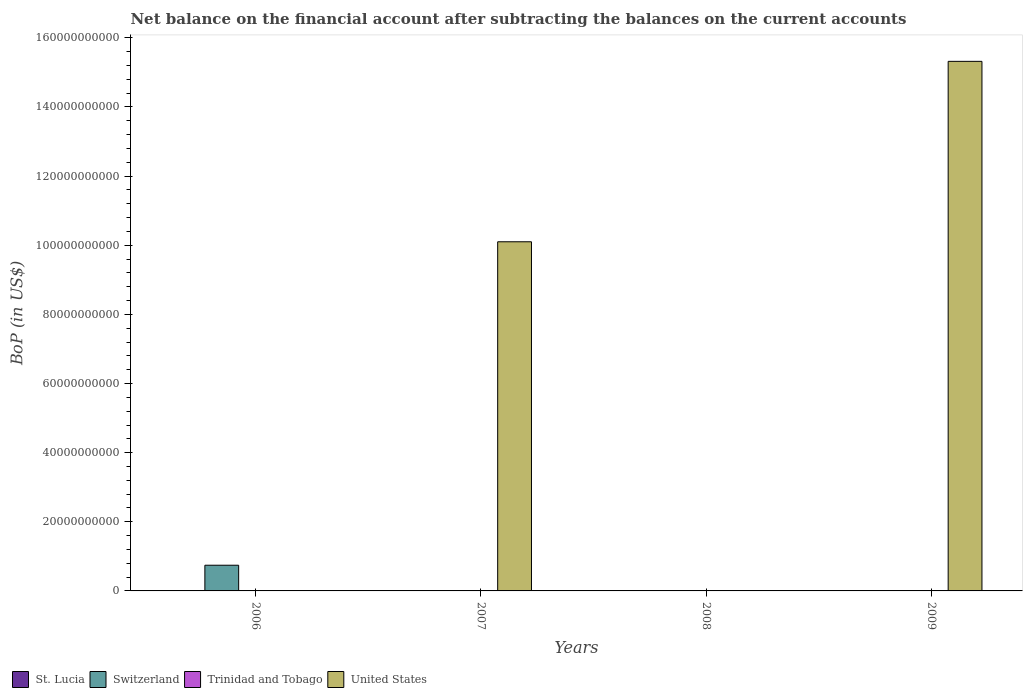Are the number of bars on each tick of the X-axis equal?
Your answer should be very brief. No. How many bars are there on the 3rd tick from the left?
Offer a very short reply. 1. How many bars are there on the 4th tick from the right?
Ensure brevity in your answer.  2. What is the label of the 1st group of bars from the left?
Provide a short and direct response. 2006. In how many cases, is the number of bars for a given year not equal to the number of legend labels?
Offer a very short reply. 4. What is the Balance of Payments in Trinidad and Tobago in 2008?
Offer a terse response. 9.70e+07. Across all years, what is the maximum Balance of Payments in St. Lucia?
Your response must be concise. 2.96e+06. Across all years, what is the minimum Balance of Payments in St. Lucia?
Provide a succinct answer. 0. What is the total Balance of Payments in United States in the graph?
Offer a terse response. 2.54e+11. What is the difference between the Balance of Payments in United States in 2007 and that in 2009?
Keep it short and to the point. -5.22e+1. What is the difference between the Balance of Payments in United States in 2009 and the Balance of Payments in Trinidad and Tobago in 2006?
Ensure brevity in your answer.  1.53e+11. What is the average Balance of Payments in Switzerland per year?
Offer a very short reply. 1.86e+09. In the year 2006, what is the difference between the Balance of Payments in St. Lucia and Balance of Payments in Switzerland?
Your answer should be very brief. -7.43e+09. What is the ratio of the Balance of Payments in Trinidad and Tobago in 2008 to that in 2009?
Keep it short and to the point. 13.61. What is the difference between the highest and the lowest Balance of Payments in Switzerland?
Your answer should be very brief. 7.43e+09. In how many years, is the Balance of Payments in St. Lucia greater than the average Balance of Payments in St. Lucia taken over all years?
Make the answer very short. 1. Is it the case that in every year, the sum of the Balance of Payments in St. Lucia and Balance of Payments in United States is greater than the sum of Balance of Payments in Switzerland and Balance of Payments in Trinidad and Tobago?
Your answer should be very brief. No. How many bars are there?
Offer a very short reply. 7. How many years are there in the graph?
Provide a succinct answer. 4. What is the difference between two consecutive major ticks on the Y-axis?
Your answer should be compact. 2.00e+1. Does the graph contain grids?
Provide a succinct answer. No. Where does the legend appear in the graph?
Provide a succinct answer. Bottom left. How are the legend labels stacked?
Make the answer very short. Horizontal. What is the title of the graph?
Your answer should be compact. Net balance on the financial account after subtracting the balances on the current accounts. Does "Thailand" appear as one of the legend labels in the graph?
Make the answer very short. No. What is the label or title of the X-axis?
Give a very brief answer. Years. What is the label or title of the Y-axis?
Offer a very short reply. BoP (in US$). What is the BoP (in US$) of St. Lucia in 2006?
Your response must be concise. 2.96e+06. What is the BoP (in US$) in Switzerland in 2006?
Provide a short and direct response. 7.43e+09. What is the BoP (in US$) of United States in 2006?
Your answer should be compact. 0. What is the BoP (in US$) in St. Lucia in 2007?
Provide a succinct answer. 4.53e+04. What is the BoP (in US$) of Switzerland in 2007?
Ensure brevity in your answer.  0. What is the BoP (in US$) in Trinidad and Tobago in 2007?
Offer a very short reply. 0. What is the BoP (in US$) of United States in 2007?
Keep it short and to the point. 1.01e+11. What is the BoP (in US$) in St. Lucia in 2008?
Make the answer very short. 0. What is the BoP (in US$) in Switzerland in 2008?
Give a very brief answer. 0. What is the BoP (in US$) of Trinidad and Tobago in 2008?
Your answer should be compact. 9.70e+07. What is the BoP (in US$) in United States in 2008?
Offer a terse response. 0. What is the BoP (in US$) in Switzerland in 2009?
Keep it short and to the point. 0. What is the BoP (in US$) in Trinidad and Tobago in 2009?
Offer a terse response. 7.12e+06. What is the BoP (in US$) in United States in 2009?
Your answer should be compact. 1.53e+11. Across all years, what is the maximum BoP (in US$) in St. Lucia?
Give a very brief answer. 2.96e+06. Across all years, what is the maximum BoP (in US$) of Switzerland?
Your answer should be compact. 7.43e+09. Across all years, what is the maximum BoP (in US$) of Trinidad and Tobago?
Give a very brief answer. 9.70e+07. Across all years, what is the maximum BoP (in US$) of United States?
Make the answer very short. 1.53e+11. Across all years, what is the minimum BoP (in US$) of St. Lucia?
Your answer should be very brief. 0. Across all years, what is the minimum BoP (in US$) in Trinidad and Tobago?
Your response must be concise. 0. What is the total BoP (in US$) in St. Lucia in the graph?
Provide a succinct answer. 3.01e+06. What is the total BoP (in US$) of Switzerland in the graph?
Keep it short and to the point. 7.43e+09. What is the total BoP (in US$) of Trinidad and Tobago in the graph?
Ensure brevity in your answer.  1.04e+08. What is the total BoP (in US$) in United States in the graph?
Make the answer very short. 2.54e+11. What is the difference between the BoP (in US$) of St. Lucia in 2006 and that in 2007?
Offer a terse response. 2.92e+06. What is the difference between the BoP (in US$) in United States in 2007 and that in 2009?
Make the answer very short. -5.22e+1. What is the difference between the BoP (in US$) in Trinidad and Tobago in 2008 and that in 2009?
Provide a short and direct response. 8.98e+07. What is the difference between the BoP (in US$) in St. Lucia in 2006 and the BoP (in US$) in United States in 2007?
Provide a succinct answer. -1.01e+11. What is the difference between the BoP (in US$) in Switzerland in 2006 and the BoP (in US$) in United States in 2007?
Your answer should be compact. -9.36e+1. What is the difference between the BoP (in US$) in St. Lucia in 2006 and the BoP (in US$) in Trinidad and Tobago in 2008?
Your answer should be compact. -9.40e+07. What is the difference between the BoP (in US$) in Switzerland in 2006 and the BoP (in US$) in Trinidad and Tobago in 2008?
Make the answer very short. 7.34e+09. What is the difference between the BoP (in US$) in St. Lucia in 2006 and the BoP (in US$) in Trinidad and Tobago in 2009?
Your answer should be compact. -4.16e+06. What is the difference between the BoP (in US$) in St. Lucia in 2006 and the BoP (in US$) in United States in 2009?
Make the answer very short. -1.53e+11. What is the difference between the BoP (in US$) of Switzerland in 2006 and the BoP (in US$) of Trinidad and Tobago in 2009?
Offer a very short reply. 7.43e+09. What is the difference between the BoP (in US$) in Switzerland in 2006 and the BoP (in US$) in United States in 2009?
Keep it short and to the point. -1.46e+11. What is the difference between the BoP (in US$) of St. Lucia in 2007 and the BoP (in US$) of Trinidad and Tobago in 2008?
Offer a terse response. -9.69e+07. What is the difference between the BoP (in US$) of St. Lucia in 2007 and the BoP (in US$) of Trinidad and Tobago in 2009?
Offer a terse response. -7.08e+06. What is the difference between the BoP (in US$) of St. Lucia in 2007 and the BoP (in US$) of United States in 2009?
Provide a short and direct response. -1.53e+11. What is the difference between the BoP (in US$) in Trinidad and Tobago in 2008 and the BoP (in US$) in United States in 2009?
Give a very brief answer. -1.53e+11. What is the average BoP (in US$) of St. Lucia per year?
Provide a succinct answer. 7.52e+05. What is the average BoP (in US$) in Switzerland per year?
Make the answer very short. 1.86e+09. What is the average BoP (in US$) of Trinidad and Tobago per year?
Your answer should be compact. 2.60e+07. What is the average BoP (in US$) in United States per year?
Your response must be concise. 6.36e+1. In the year 2006, what is the difference between the BoP (in US$) of St. Lucia and BoP (in US$) of Switzerland?
Make the answer very short. -7.43e+09. In the year 2007, what is the difference between the BoP (in US$) of St. Lucia and BoP (in US$) of United States?
Offer a very short reply. -1.01e+11. In the year 2009, what is the difference between the BoP (in US$) of Trinidad and Tobago and BoP (in US$) of United States?
Your answer should be very brief. -1.53e+11. What is the ratio of the BoP (in US$) in St. Lucia in 2006 to that in 2007?
Offer a very short reply. 65.34. What is the ratio of the BoP (in US$) in United States in 2007 to that in 2009?
Your response must be concise. 0.66. What is the ratio of the BoP (in US$) in Trinidad and Tobago in 2008 to that in 2009?
Give a very brief answer. 13.61. What is the difference between the highest and the lowest BoP (in US$) of St. Lucia?
Keep it short and to the point. 2.96e+06. What is the difference between the highest and the lowest BoP (in US$) of Switzerland?
Your answer should be very brief. 7.43e+09. What is the difference between the highest and the lowest BoP (in US$) in Trinidad and Tobago?
Keep it short and to the point. 9.70e+07. What is the difference between the highest and the lowest BoP (in US$) in United States?
Your answer should be very brief. 1.53e+11. 